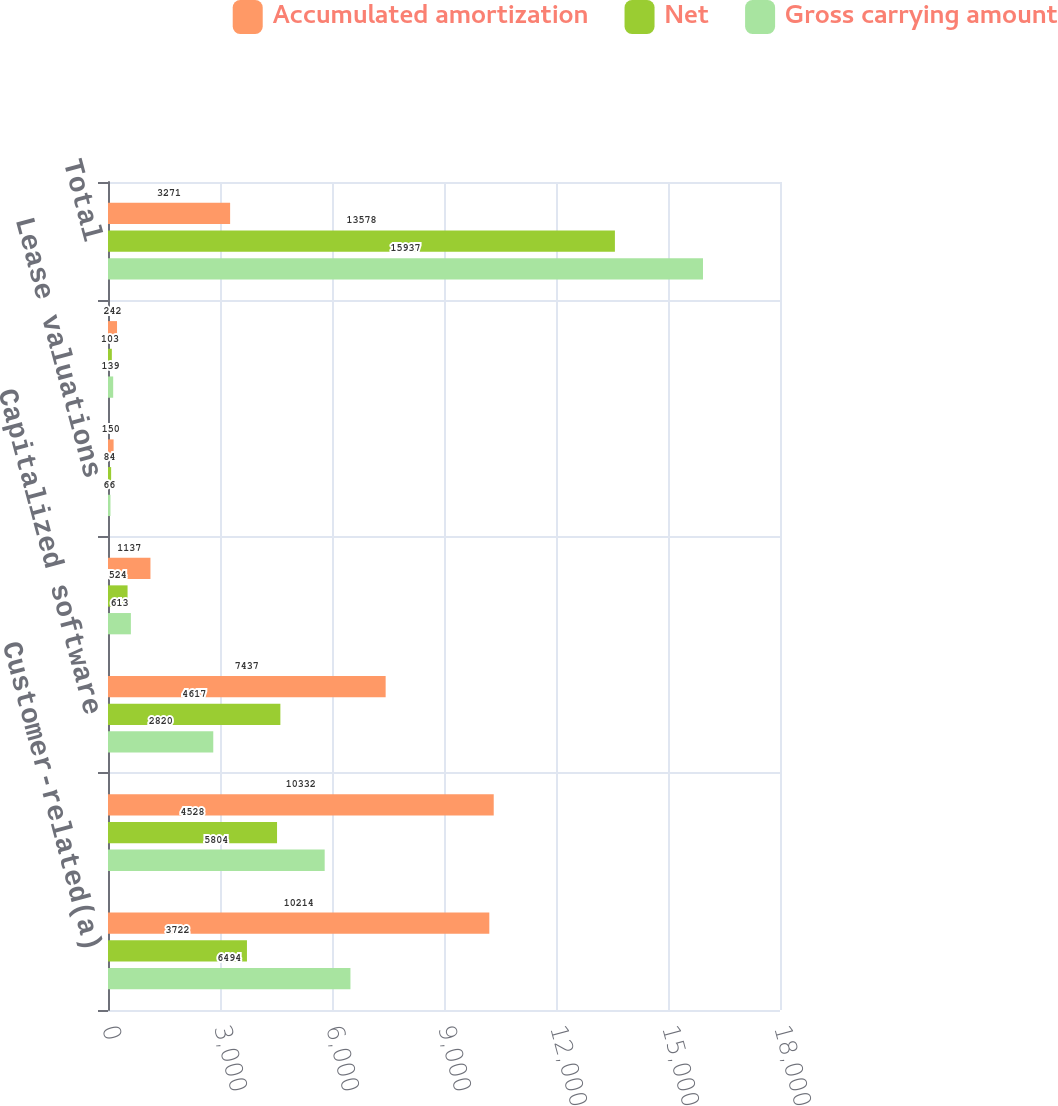Convert chart. <chart><loc_0><loc_0><loc_500><loc_500><stacked_bar_chart><ecel><fcel>Customer-related(a)<fcel>Patents and technology<fcel>Capitalized software<fcel>Trademarks<fcel>Lease valuations<fcel>All other<fcel>Total<nl><fcel>Accumulated amortization<fcel>10214<fcel>10332<fcel>7437<fcel>1137<fcel>150<fcel>242<fcel>3271<nl><fcel>Net<fcel>3722<fcel>4528<fcel>4617<fcel>524<fcel>84<fcel>103<fcel>13578<nl><fcel>Gross carrying amount<fcel>6494<fcel>5804<fcel>2820<fcel>613<fcel>66<fcel>139<fcel>15937<nl></chart> 